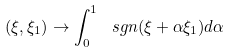<formula> <loc_0><loc_0><loc_500><loc_500>( \xi , \xi _ { 1 } ) \rightarrow \int _ { 0 } ^ { 1 } \ s g n ( \xi + \alpha \xi _ { 1 } ) d \alpha</formula> 